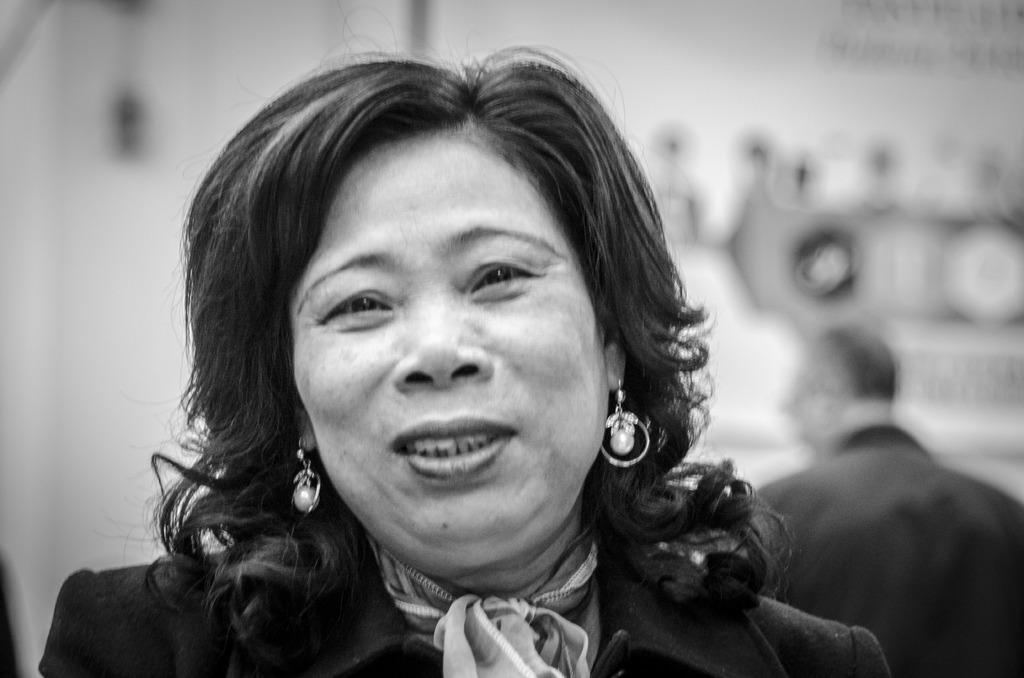Who is the main subject in the foreground of the image? There is a woman in the foreground of the image. Can you describe the man's position in the image? The man is on the right side of the image and is facing towards the back side. How would you describe the background of the image? The background of the image is blurred. What type of breakfast is the woman having in the image? There is no indication of breakfast in the image; it only shows a woman in the foreground and a man on the right side. 